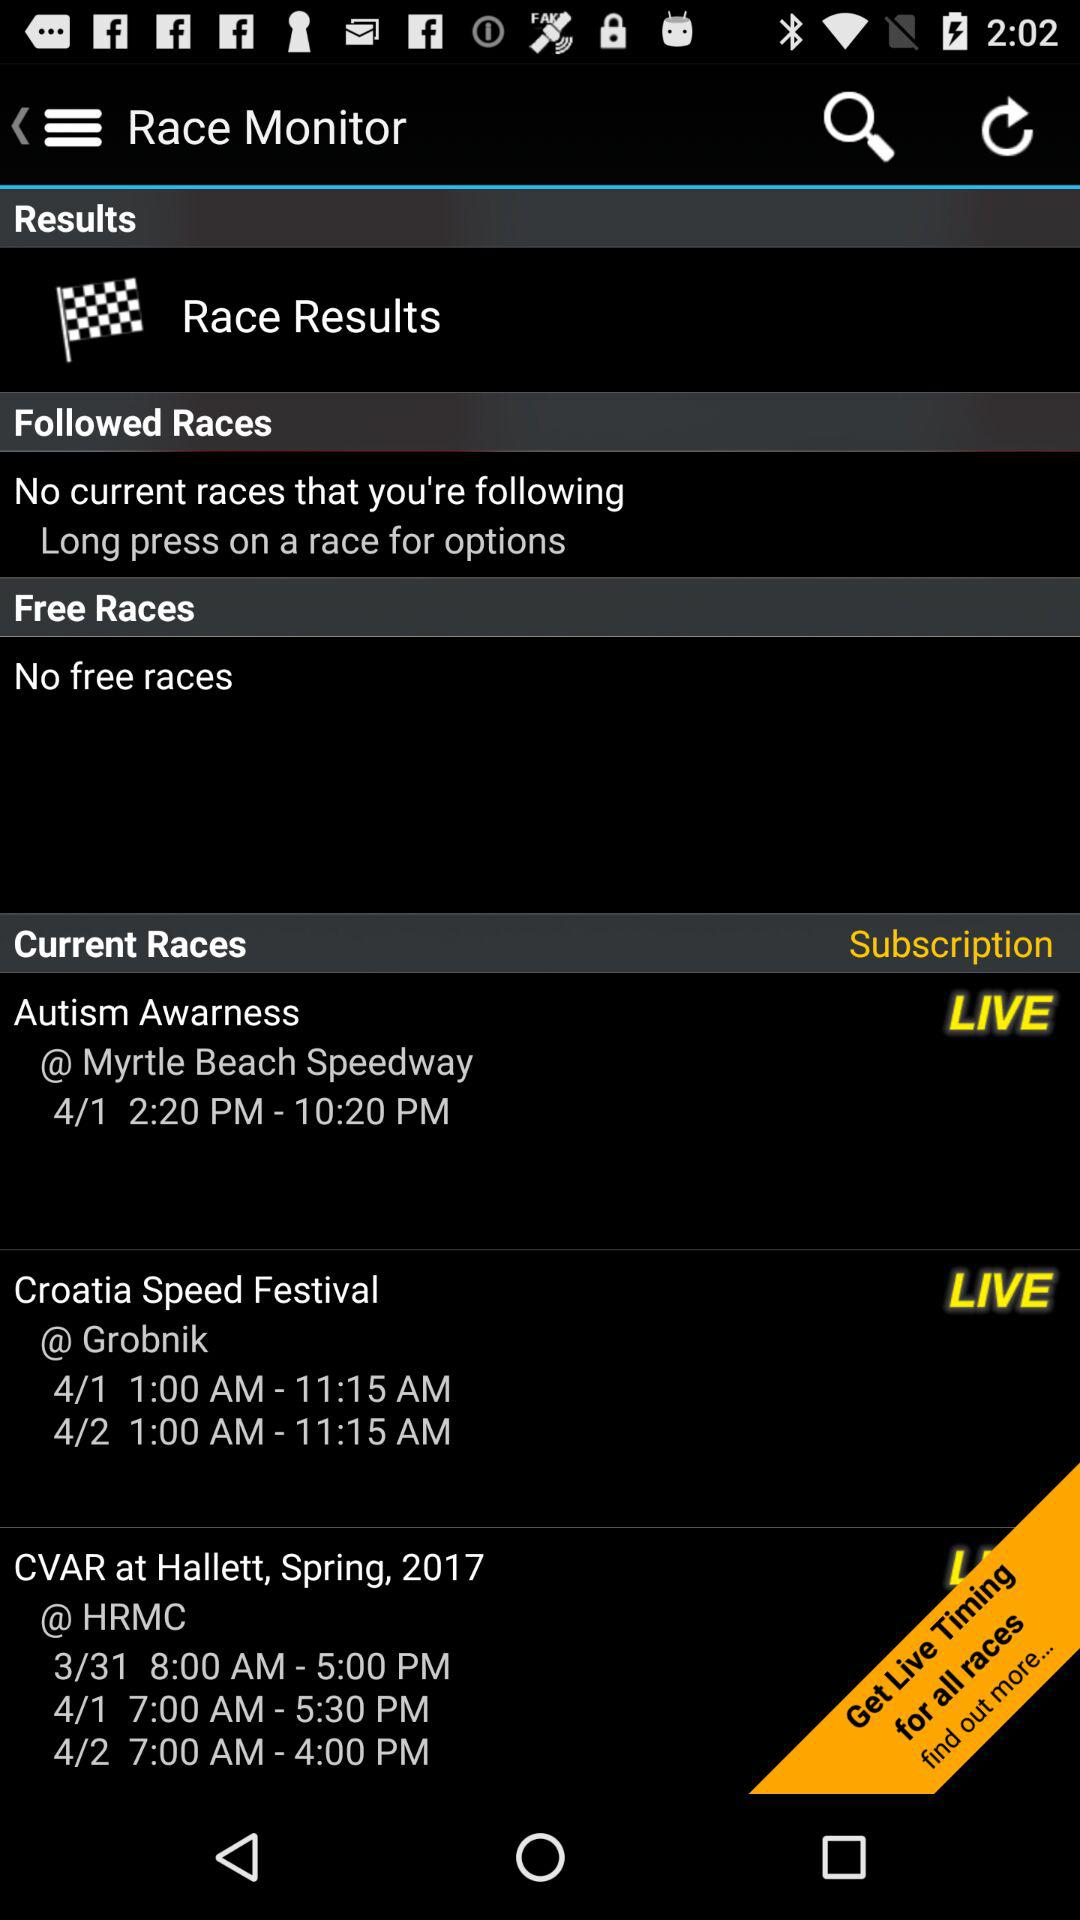How many free races are there? There are no free races. 